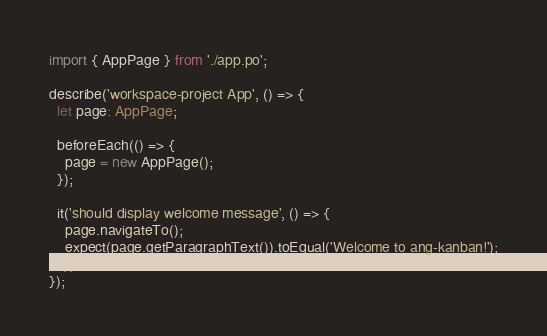Convert code to text. <code><loc_0><loc_0><loc_500><loc_500><_TypeScript_>import { AppPage } from './app.po';

describe('workspace-project App', () => {
  let page: AppPage;

  beforeEach(() => {
    page = new AppPage();
  });

  it('should display welcome message', () => {
    page.navigateTo();
    expect(page.getParagraphText()).toEqual('Welcome to ang-kanban!');
  });
});
</code> 